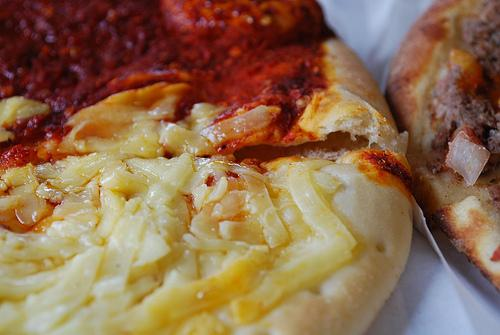What is the bright and red feature in the image? The bright and red feature in the image is the pizza sauce. What type of food is shown in this image? The image displays two pizzas with various toppings. What is the main color of the cheese on the pizzas? The main color of the cheese on the pizzas is yellow. Describe the size difference between the pizzas in the image. One pizza is bigger than the other. Give a brief description of the entire scene. The image depicts two pizzas next to each other with various toppings, such as red sauce, onions, and melted cheese, on a white cloth. What toppings are visible on the pizza? Visible toppings include red sauce, melted yellow cheese, onions, and meat. Describe the appearance of the crust on the pizzas. The crust looks good, is light yellow, toasted brown, with some burnt edges and small holes, and is soft and doughy. What is the main color of the sauce on the pizzas? The main color of the sauce on the pizzas is red. In this scene, what is the white fabric beneath the pizzas? There is a white cloth under the food. What kind of task can this image be used for in a product advertisement? The image can be used to showcase the deliciousness and variety of toppings in a pizza restaurant's offerings. 